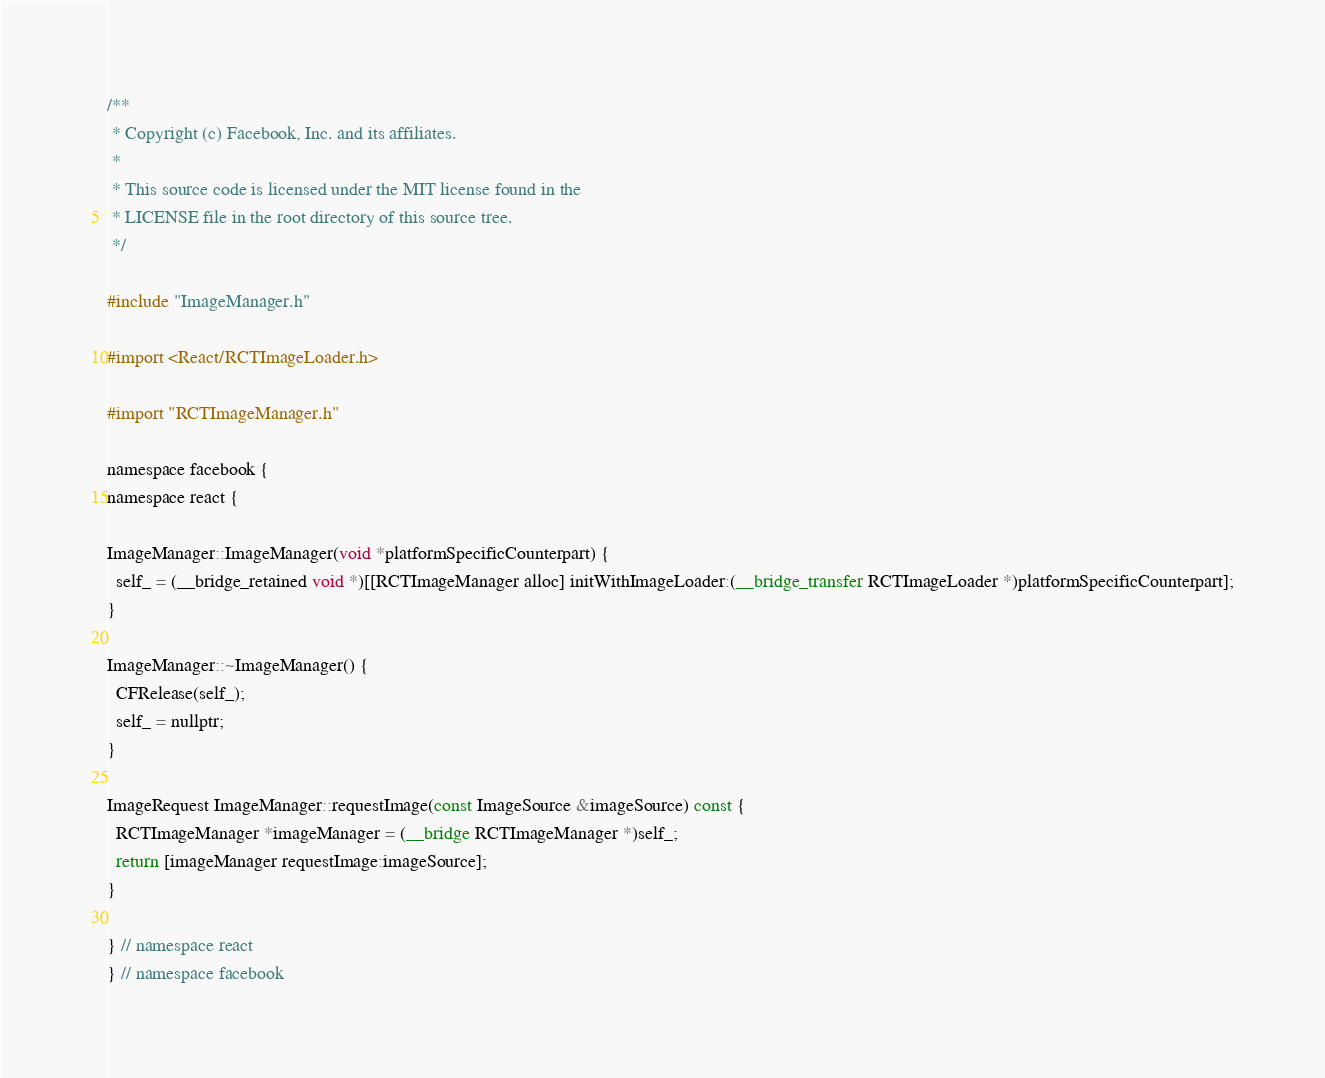Convert code to text. <code><loc_0><loc_0><loc_500><loc_500><_ObjectiveC_>/**
 * Copyright (c) Facebook, Inc. and its affiliates.
 *
 * This source code is licensed under the MIT license found in the
 * LICENSE file in the root directory of this source tree.
 */

#include "ImageManager.h"

#import <React/RCTImageLoader.h>

#import "RCTImageManager.h"

namespace facebook {
namespace react {

ImageManager::ImageManager(void *platformSpecificCounterpart) {
  self_ = (__bridge_retained void *)[[RCTImageManager alloc] initWithImageLoader:(__bridge_transfer RCTImageLoader *)platformSpecificCounterpart];
}

ImageManager::~ImageManager() {
  CFRelease(self_);
  self_ = nullptr;
}

ImageRequest ImageManager::requestImage(const ImageSource &imageSource) const {
  RCTImageManager *imageManager = (__bridge RCTImageManager *)self_;
  return [imageManager requestImage:imageSource];
}

} // namespace react
} // namespace facebook
</code> 